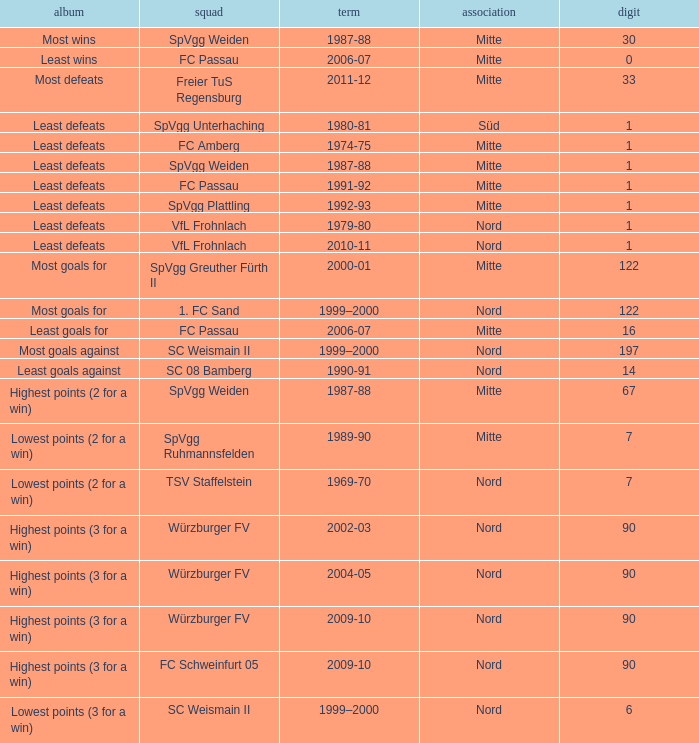What league has most wins as the record? Mitte. 